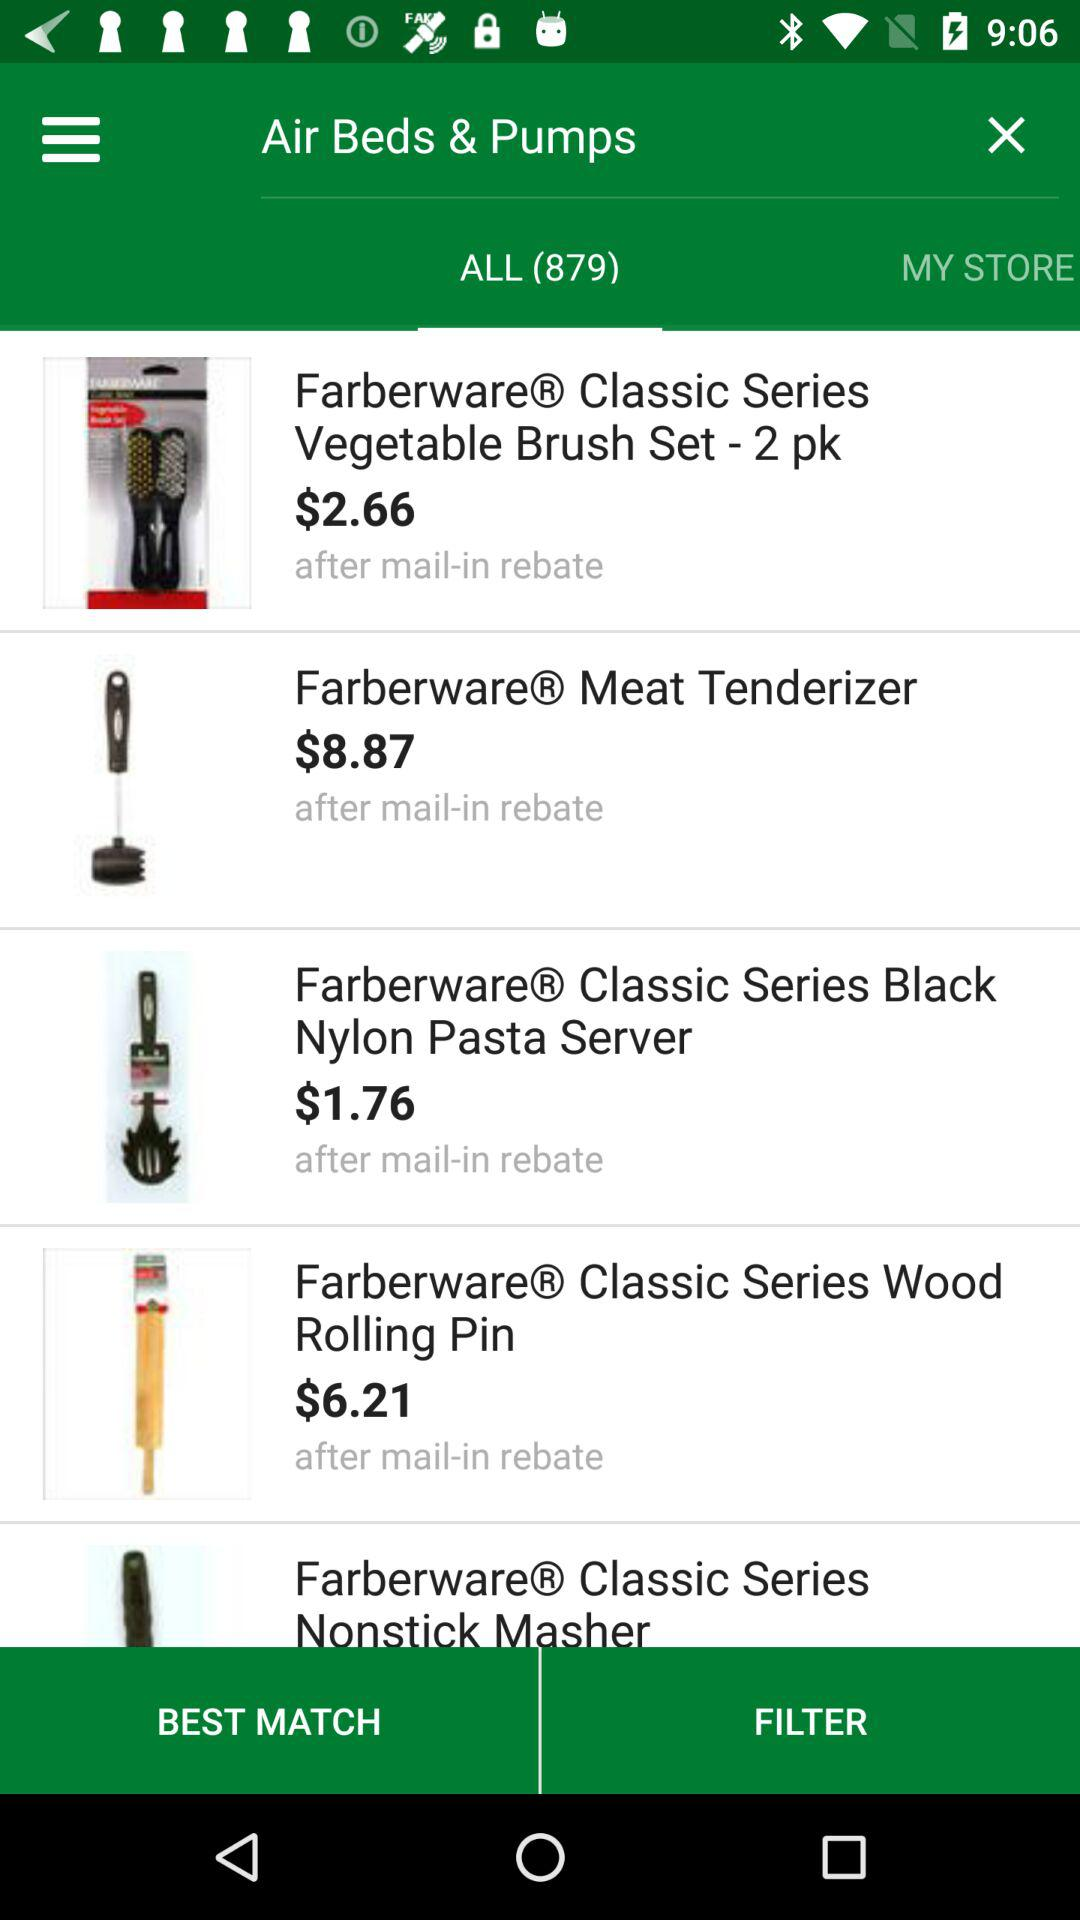What is the cost of classic series nonstick masher?
When the provided information is insufficient, respond with <no answer>. <no answer> 